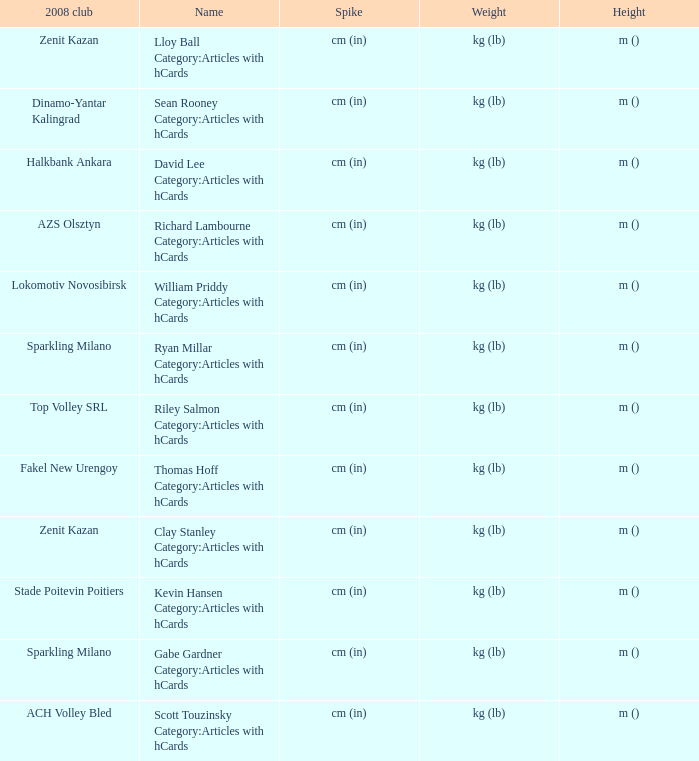What name has Fakel New Urengoy as the 2008 club? Thomas Hoff Category:Articles with hCards. 